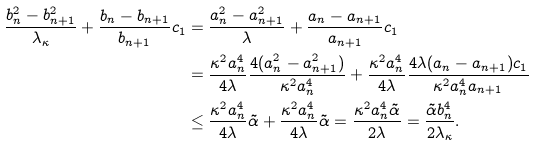Convert formula to latex. <formula><loc_0><loc_0><loc_500><loc_500>\frac { b _ { n } ^ { 2 } - b _ { n + 1 } ^ { 2 } } { \lambda _ { \kappa } } + \frac { b _ { n } - b _ { n + 1 } } { b _ { n + 1 } } c _ { 1 } & = \frac { a _ { n } ^ { 2 } - a _ { n + 1 } ^ { 2 } } { \lambda } + \frac { a _ { n } - a _ { n + 1 } } { a _ { n + 1 } } c _ { 1 } \\ & = \frac { \kappa ^ { 2 } a _ { n } ^ { 4 } } { 4 \lambda } \frac { 4 ( a _ { n } ^ { 2 } - a _ { n + 1 } ^ { 2 } ) } { \kappa ^ { 2 } a _ { n } ^ { 4 } } + \frac { \kappa ^ { 2 } a _ { n } ^ { 4 } } { 4 \lambda } \frac { 4 \lambda ( a _ { n } - a _ { n + 1 } ) c _ { 1 } } { \kappa ^ { 2 } a _ { n } ^ { 4 } a _ { n + 1 } } \\ & \leq \frac { \kappa ^ { 2 } a _ { n } ^ { 4 } } { 4 \lambda } \tilde { \alpha } + \frac { \kappa ^ { 2 } a _ { n } ^ { 4 } } { 4 \lambda } \tilde { \alpha } = \frac { \kappa ^ { 2 } a _ { n } ^ { 4 } \tilde { \alpha } } { 2 \lambda } = \frac { \tilde { \alpha } b _ { n } ^ { 4 } } { 2 \lambda _ { \kappa } } .</formula> 